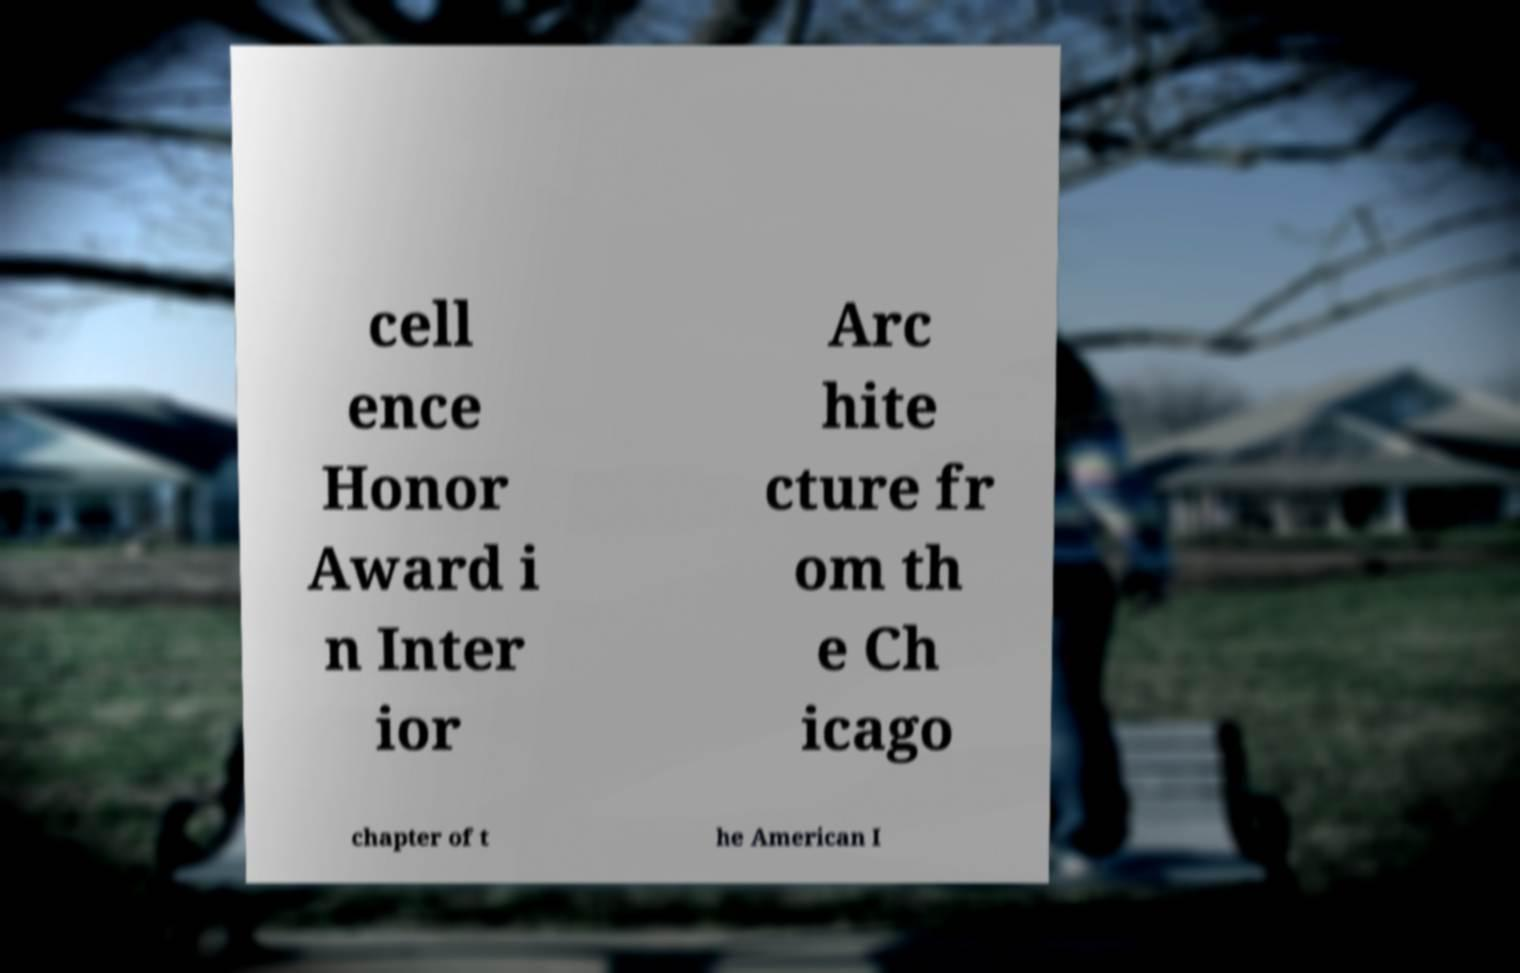For documentation purposes, I need the text within this image transcribed. Could you provide that? cell ence Honor Award i n Inter ior Arc hite cture fr om th e Ch icago chapter of t he American I 